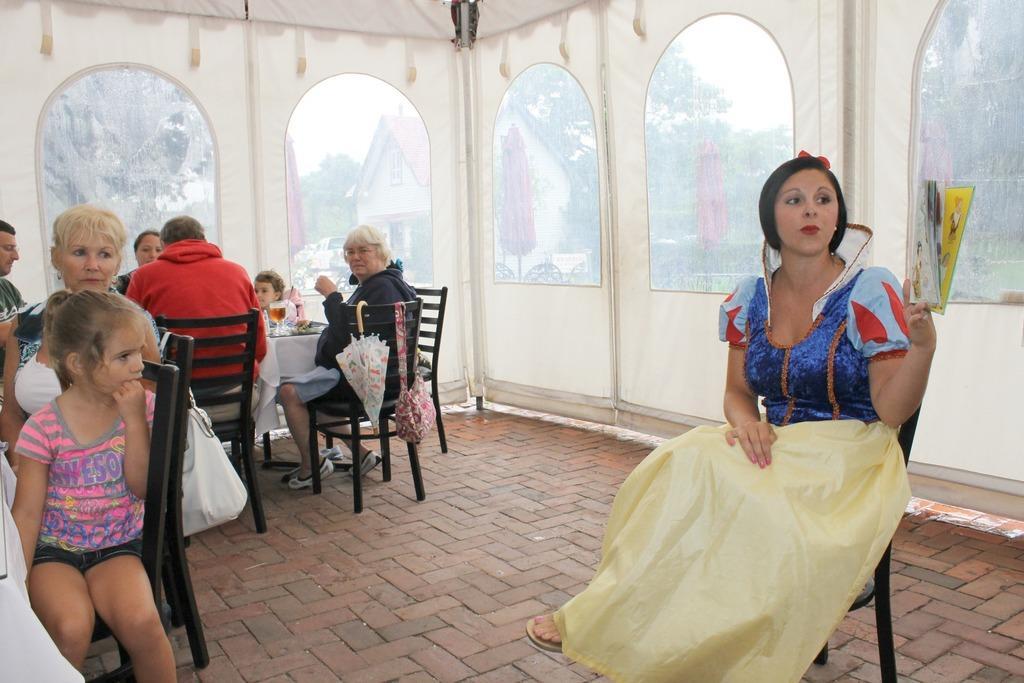Please provide a concise description of this image. There are group of people sitting in chairs and there is a table in front of them and there is a woman sitting in a chair and holding a a book in the right corner. 